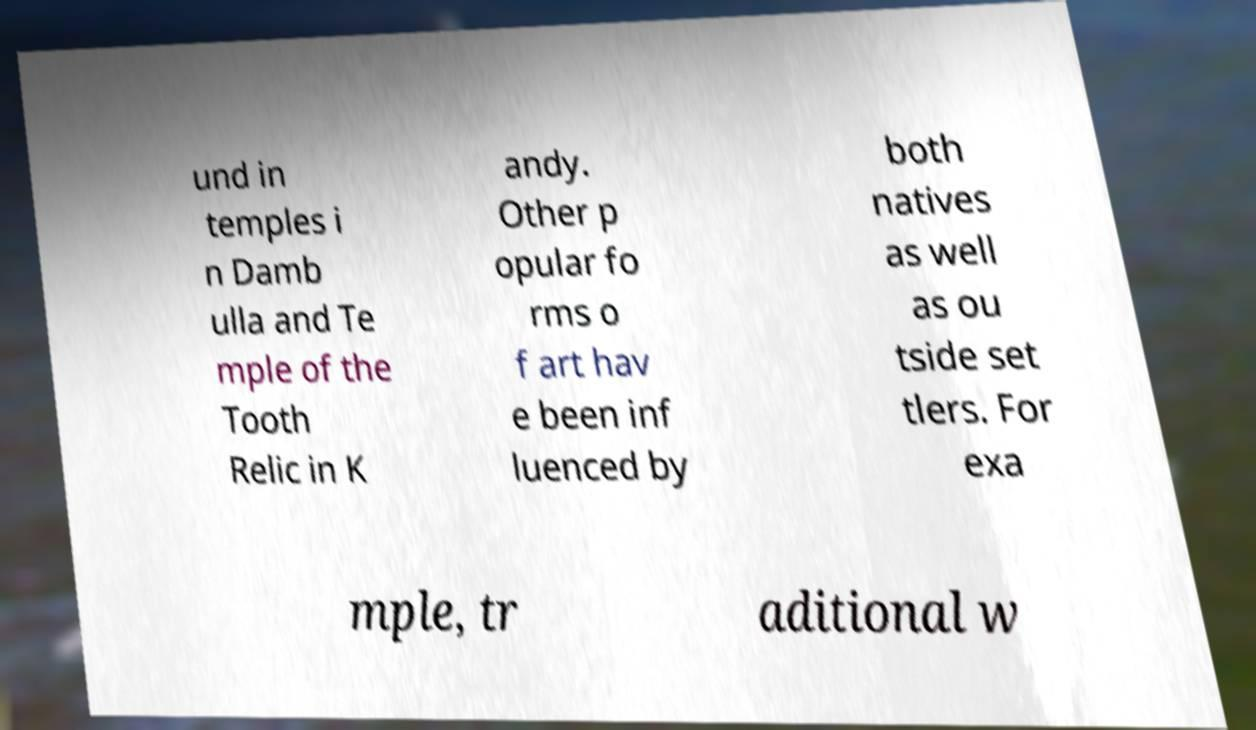I need the written content from this picture converted into text. Can you do that? und in temples i n Damb ulla and Te mple of the Tooth Relic in K andy. Other p opular fo rms o f art hav e been inf luenced by both natives as well as ou tside set tlers. For exa mple, tr aditional w 